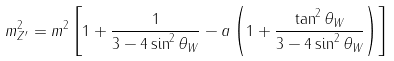Convert formula to latex. <formula><loc_0><loc_0><loc_500><loc_500>m _ { Z ^ { \prime } } ^ { 2 } = m ^ { 2 } \left [ 1 + \frac { 1 } { 3 - 4 \sin ^ { 2 } \theta _ { W } } - a \left ( 1 + \frac { \tan ^ { 2 } \theta _ { W } } { 3 - 4 \sin ^ { 2 } \theta _ { W } } \right ) \right ]</formula> 